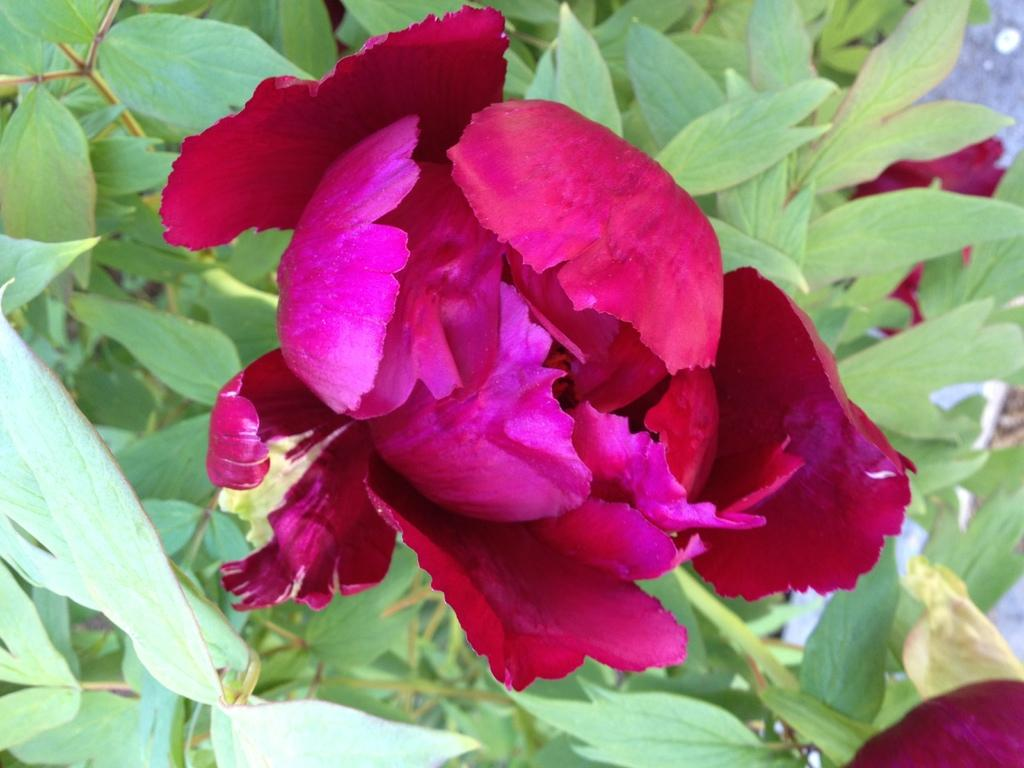What type of flower is present in the image? There is a pink color flower in the image. Where is the flower located? The flower is on a plant. Where is the lunchroom in the image? There is no mention of a lunchroom in the image, as it only features a pink color flower on a plant. 